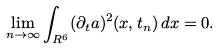<formula> <loc_0><loc_0><loc_500><loc_500>\lim _ { n \to \infty } \int _ { R ^ { 6 } } ( \partial _ { t } a ) ^ { 2 } ( x , t _ { n } ) \, d x = 0 .</formula> 